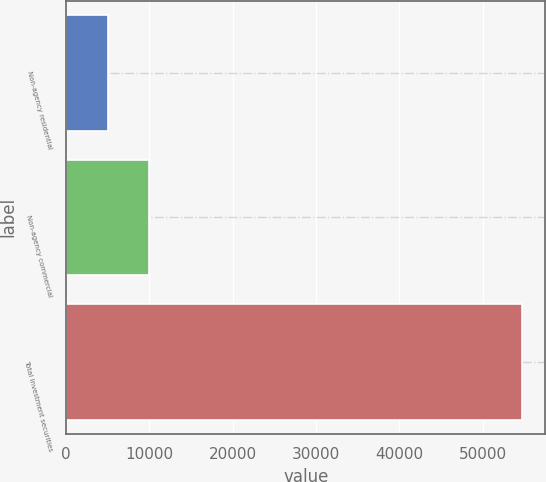<chart> <loc_0><loc_0><loc_500><loc_500><bar_chart><fcel>Non-agency residential<fcel>Non-agency commercial<fcel>Total investment securities<nl><fcel>4993<fcel>9970.6<fcel>54769<nl></chart> 